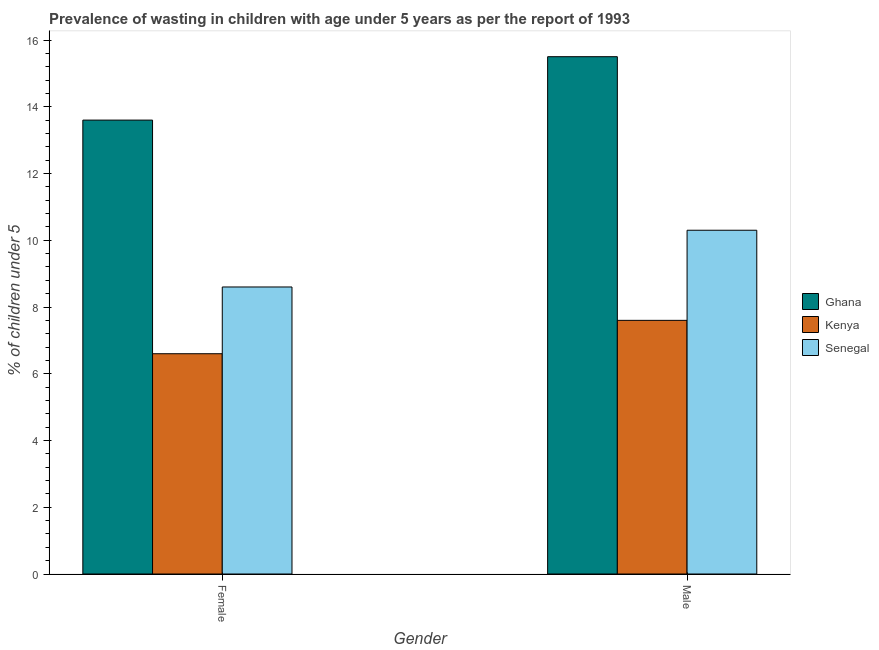How many different coloured bars are there?
Your answer should be compact. 3. How many groups of bars are there?
Your response must be concise. 2. What is the label of the 2nd group of bars from the left?
Give a very brief answer. Male. What is the percentage of undernourished male children in Senegal?
Keep it short and to the point. 10.3. Across all countries, what is the minimum percentage of undernourished male children?
Your answer should be very brief. 7.6. In which country was the percentage of undernourished male children minimum?
Provide a short and direct response. Kenya. What is the total percentage of undernourished male children in the graph?
Give a very brief answer. 33.4. What is the difference between the percentage of undernourished male children in Kenya and that in Ghana?
Offer a very short reply. -7.9. What is the difference between the percentage of undernourished female children in Ghana and the percentage of undernourished male children in Kenya?
Provide a short and direct response. 6. What is the average percentage of undernourished male children per country?
Provide a succinct answer. 11.13. What is the difference between the percentage of undernourished female children and percentage of undernourished male children in Senegal?
Provide a short and direct response. -1.7. In how many countries, is the percentage of undernourished female children greater than 11.2 %?
Your answer should be very brief. 1. What is the ratio of the percentage of undernourished male children in Senegal to that in Kenya?
Provide a short and direct response. 1.36. In how many countries, is the percentage of undernourished male children greater than the average percentage of undernourished male children taken over all countries?
Keep it short and to the point. 1. What does the 3rd bar from the left in Female represents?
Offer a very short reply. Senegal. What does the 1st bar from the right in Female represents?
Give a very brief answer. Senegal. How many bars are there?
Keep it short and to the point. 6. Are all the bars in the graph horizontal?
Offer a very short reply. No. Does the graph contain grids?
Provide a short and direct response. No. Where does the legend appear in the graph?
Your answer should be very brief. Center right. How many legend labels are there?
Provide a short and direct response. 3. How are the legend labels stacked?
Provide a short and direct response. Vertical. What is the title of the graph?
Give a very brief answer. Prevalence of wasting in children with age under 5 years as per the report of 1993. What is the label or title of the Y-axis?
Offer a terse response.  % of children under 5. What is the  % of children under 5 of Ghana in Female?
Offer a very short reply. 13.6. What is the  % of children under 5 of Kenya in Female?
Make the answer very short. 6.6. What is the  % of children under 5 in Senegal in Female?
Make the answer very short. 8.6. What is the  % of children under 5 in Ghana in Male?
Your response must be concise. 15.5. What is the  % of children under 5 of Kenya in Male?
Offer a terse response. 7.6. What is the  % of children under 5 in Senegal in Male?
Make the answer very short. 10.3. Across all Gender, what is the maximum  % of children under 5 of Kenya?
Make the answer very short. 7.6. Across all Gender, what is the maximum  % of children under 5 in Senegal?
Provide a succinct answer. 10.3. Across all Gender, what is the minimum  % of children under 5 of Ghana?
Ensure brevity in your answer.  13.6. Across all Gender, what is the minimum  % of children under 5 in Kenya?
Offer a very short reply. 6.6. Across all Gender, what is the minimum  % of children under 5 of Senegal?
Give a very brief answer. 8.6. What is the total  % of children under 5 in Ghana in the graph?
Provide a succinct answer. 29.1. What is the difference between the  % of children under 5 in Ghana in Female and the  % of children under 5 in Kenya in Male?
Keep it short and to the point. 6. What is the difference between the  % of children under 5 of Ghana in Female and the  % of children under 5 of Senegal in Male?
Give a very brief answer. 3.3. What is the difference between the  % of children under 5 of Kenya in Female and the  % of children under 5 of Senegal in Male?
Offer a terse response. -3.7. What is the average  % of children under 5 of Ghana per Gender?
Keep it short and to the point. 14.55. What is the average  % of children under 5 of Kenya per Gender?
Provide a succinct answer. 7.1. What is the average  % of children under 5 in Senegal per Gender?
Your answer should be very brief. 9.45. What is the difference between the  % of children under 5 in Ghana and  % of children under 5 in Senegal in Female?
Provide a succinct answer. 5. What is the difference between the  % of children under 5 of Kenya and  % of children under 5 of Senegal in Female?
Keep it short and to the point. -2. What is the difference between the  % of children under 5 of Ghana and  % of children under 5 of Senegal in Male?
Your answer should be very brief. 5.2. What is the ratio of the  % of children under 5 in Ghana in Female to that in Male?
Offer a very short reply. 0.88. What is the ratio of the  % of children under 5 of Kenya in Female to that in Male?
Keep it short and to the point. 0.87. What is the ratio of the  % of children under 5 of Senegal in Female to that in Male?
Ensure brevity in your answer.  0.83. What is the difference between the highest and the lowest  % of children under 5 of Ghana?
Provide a short and direct response. 1.9. 